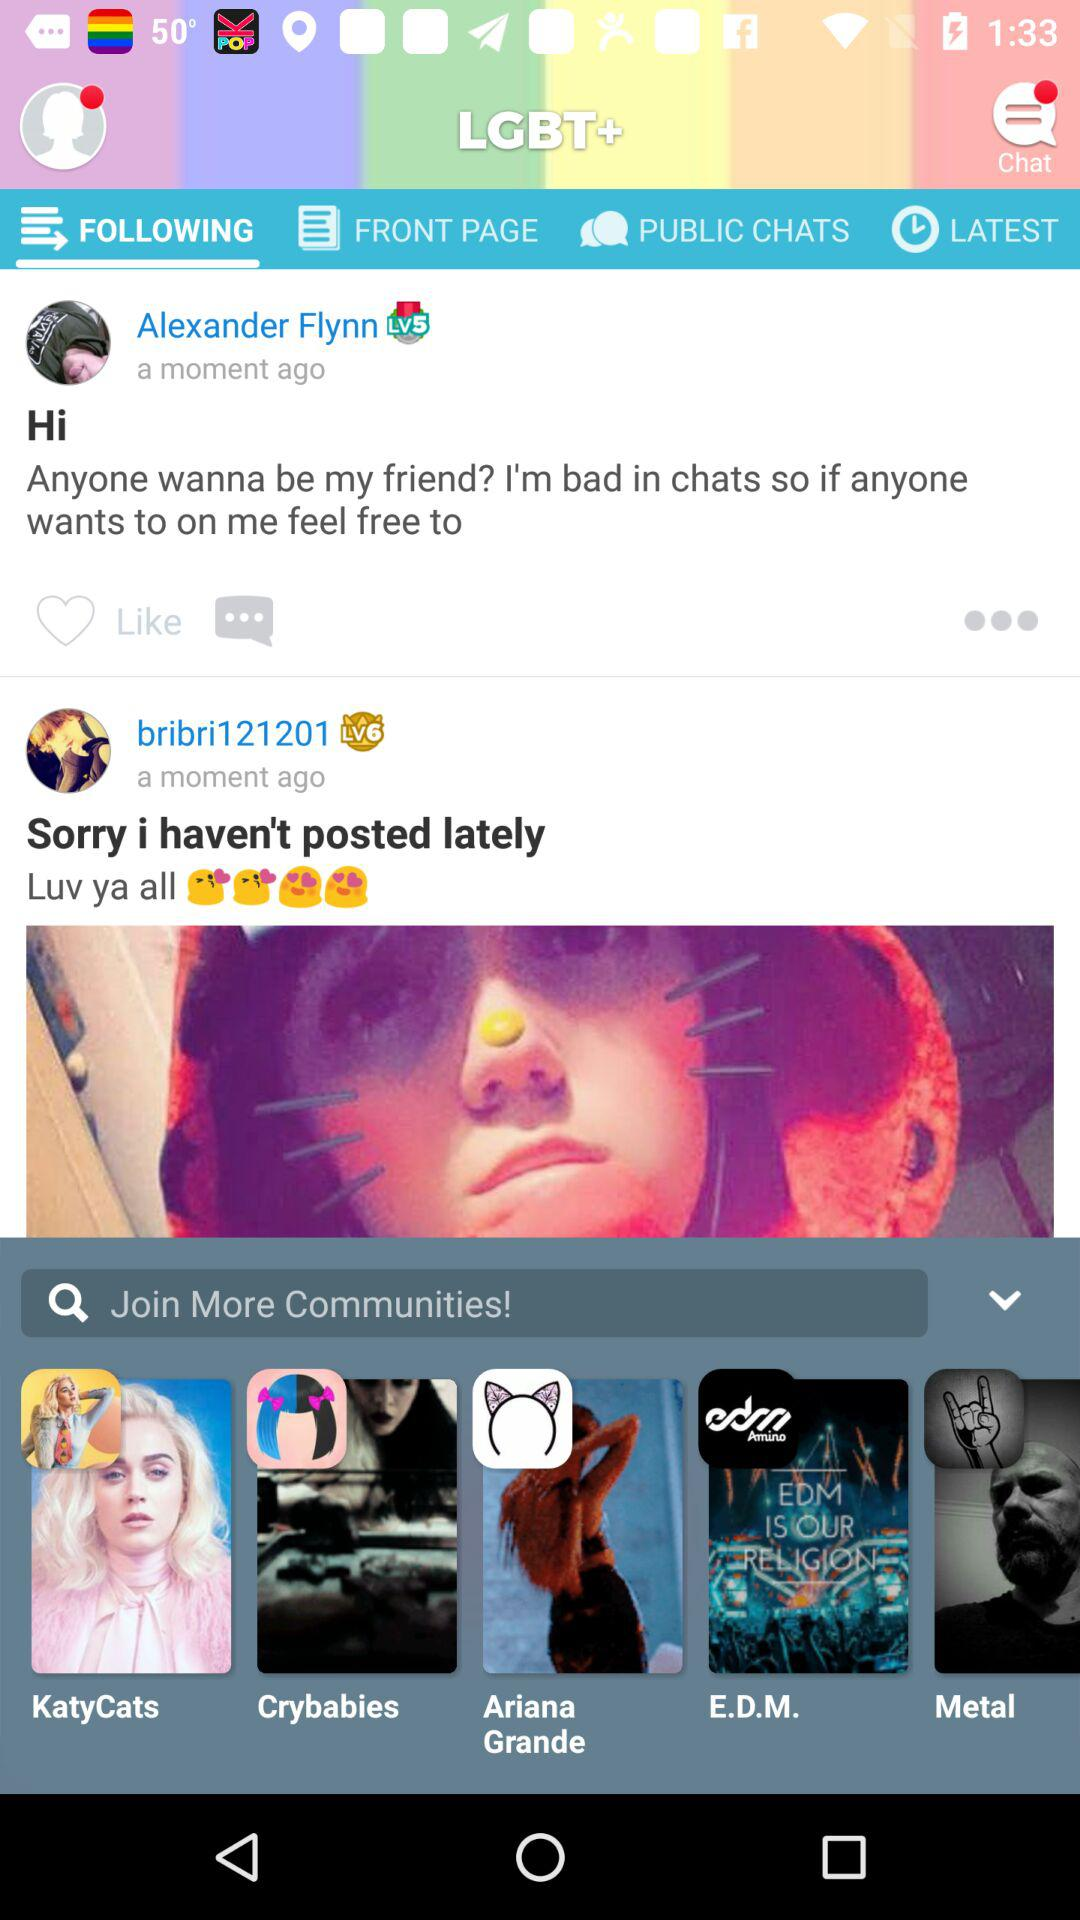What is the profile name of the person who posted "Hi"? The profile name is Alexander Flynn. 